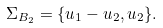<formula> <loc_0><loc_0><loc_500><loc_500>\Sigma _ { B _ { 2 } } = \{ u _ { 1 } - u _ { 2 } , u _ { 2 } \} .</formula> 